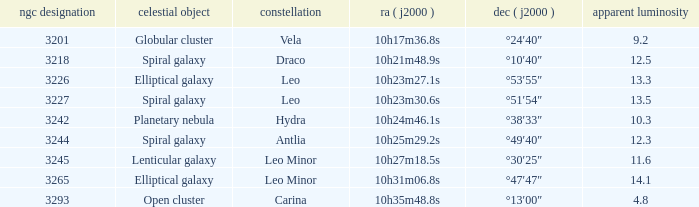What is the Apparent magnitude of a globular cluster? 9.2. 